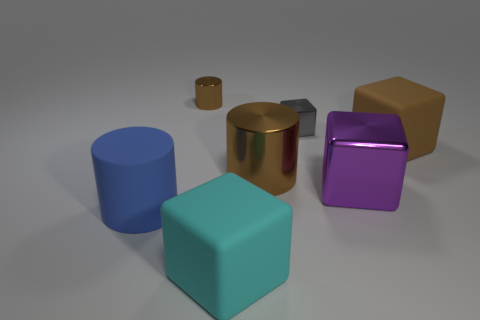Subtract all cyan cubes. How many cubes are left? 3 Add 2 tiny shiny cylinders. How many objects exist? 9 Subtract all red blocks. Subtract all gray spheres. How many blocks are left? 4 Subtract all cylinders. How many objects are left? 4 Subtract all rubber cylinders. Subtract all blue things. How many objects are left? 5 Add 5 cyan matte objects. How many cyan matte objects are left? 6 Add 2 big red shiny cylinders. How many big red shiny cylinders exist? 2 Subtract 1 brown blocks. How many objects are left? 6 